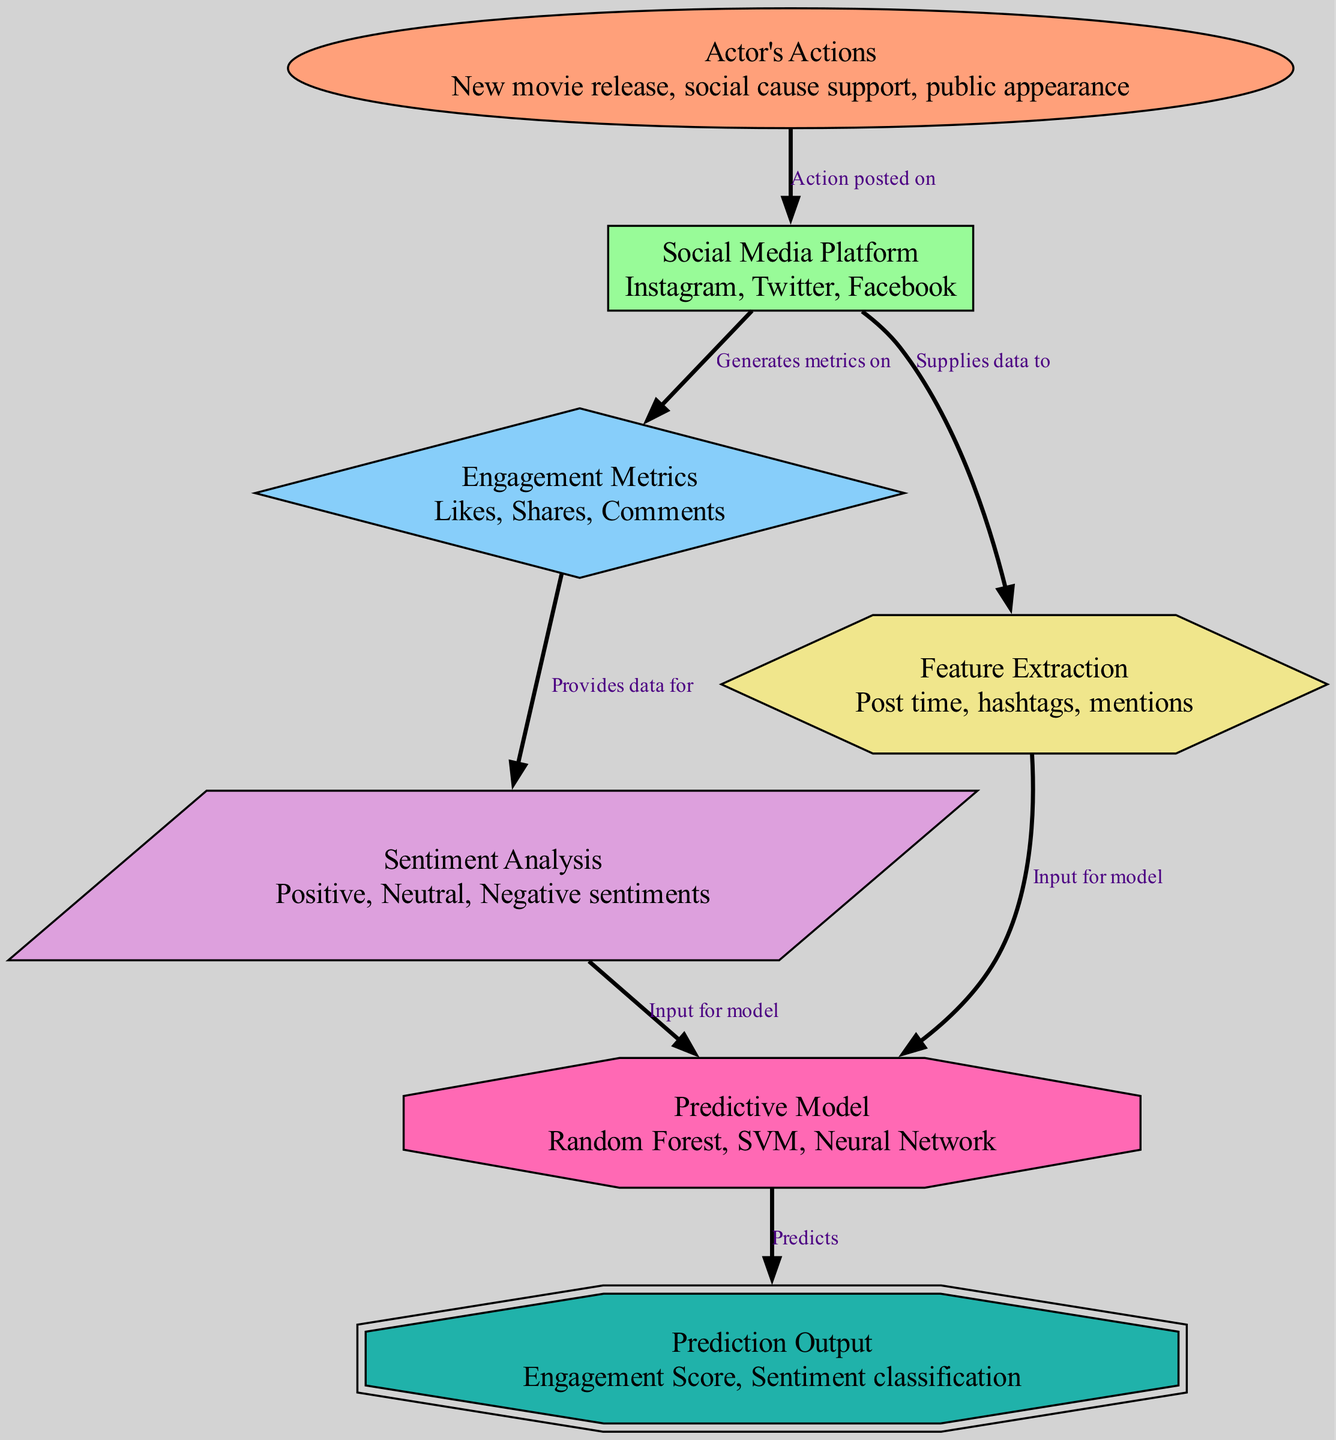What are the three types of actor's actions mentioned? The diagram lists "New movie release, social cause support, public appearance" as the description of the "Actor's Actions" node.
Answer: New movie release, social cause support, public appearance Which social media platforms are identified in the diagram? From the "Social Media Platform" node, we can see that the platforms listed are "Instagram, Twitter, Facebook."
Answer: Instagram, Twitter, Facebook How many engagement metrics are there according to the diagram? The diagram categorizes "Likes, Shares, Comments" under the "Engagement Metrics" node, totaling three metrics.
Answer: 3 What relationship does the "Actor's Actions" have with "Social Media Platform"? The edge connected from "Actor's Actions" to "Social Media Platform" indicates that actor's actions are "Action posted on" social media platforms.
Answer: Action posted on Which node serves as input for the predictive model? The edges show that both "Sentiment Analysis" and "Feature Extraction" provide input data for the "Predictive Model." Hence, both nodes are sources for this input.
Answer: Sentiment Analysis, Feature Extraction What is predicted by the predictive model? The "Predictive Model" node outputs the "Prediction Output" which includes "Engagement Score, Sentiment classification."
Answer: Engagement Score, Sentiment classification How does the "Social Media Platform" influence engagement metrics? The connection indicates that "Social Media Platform" "Generates metrics on" the "Engagement Metrics," demonstrating the influence of the platform on engagement outcomes.
Answer: Generates metrics on What kind of input does the predictive model receive from sentiment analysis? The "Sentiment Analysis" node provides data classified as "Positive, Neutral, Negative sentiments," which serves as input for the predictive model.
Answer: Positive, Neutral, Negative sentiments 